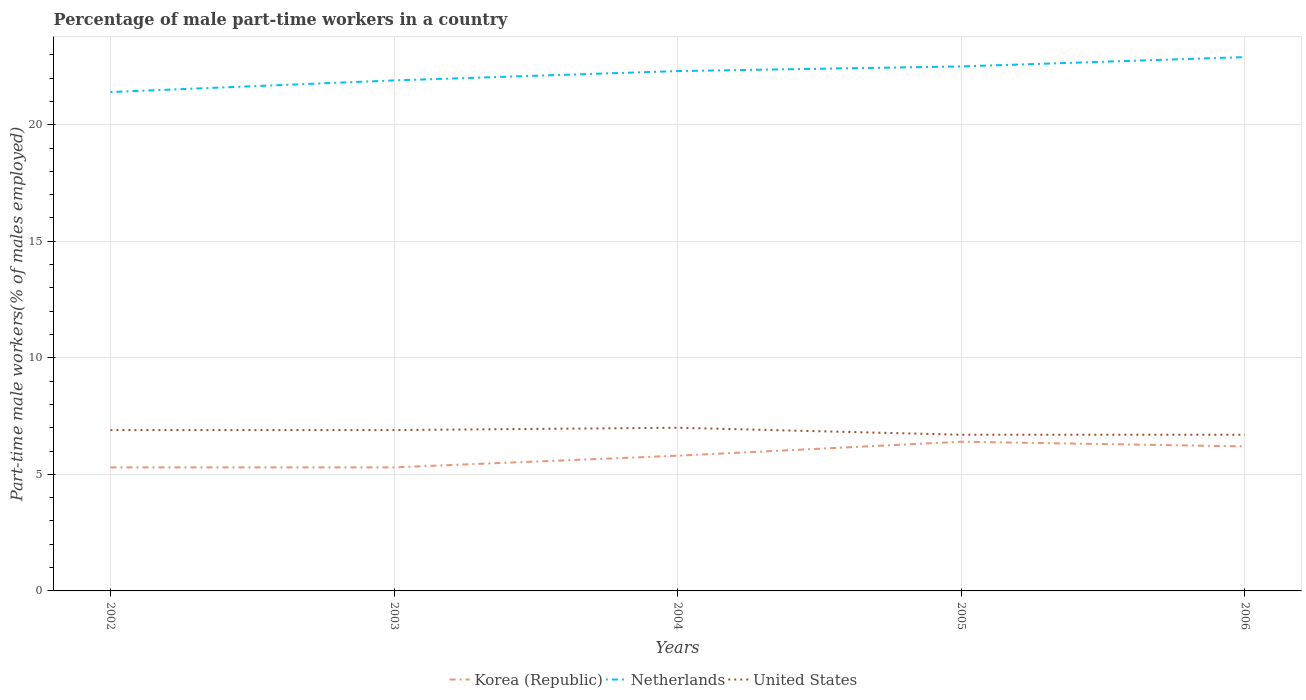How many different coloured lines are there?
Give a very brief answer. 3. Is the number of lines equal to the number of legend labels?
Your answer should be very brief. Yes. Across all years, what is the maximum percentage of male part-time workers in Netherlands?
Your response must be concise. 21.4. What is the total percentage of male part-time workers in United States in the graph?
Make the answer very short. 0. What is the difference between the highest and the second highest percentage of male part-time workers in Korea (Republic)?
Provide a short and direct response. 1.1. What is the difference between the highest and the lowest percentage of male part-time workers in Korea (Republic)?
Your answer should be compact. 3. How many lines are there?
Offer a very short reply. 3. Are the values on the major ticks of Y-axis written in scientific E-notation?
Provide a short and direct response. No. How are the legend labels stacked?
Provide a short and direct response. Horizontal. What is the title of the graph?
Your response must be concise. Percentage of male part-time workers in a country. What is the label or title of the X-axis?
Your answer should be compact. Years. What is the label or title of the Y-axis?
Give a very brief answer. Part-time male workers(% of males employed). What is the Part-time male workers(% of males employed) of Korea (Republic) in 2002?
Your response must be concise. 5.3. What is the Part-time male workers(% of males employed) in Netherlands in 2002?
Keep it short and to the point. 21.4. What is the Part-time male workers(% of males employed) of United States in 2002?
Your response must be concise. 6.9. What is the Part-time male workers(% of males employed) of Korea (Republic) in 2003?
Your response must be concise. 5.3. What is the Part-time male workers(% of males employed) in Netherlands in 2003?
Ensure brevity in your answer.  21.9. What is the Part-time male workers(% of males employed) of United States in 2003?
Provide a short and direct response. 6.9. What is the Part-time male workers(% of males employed) of Korea (Republic) in 2004?
Offer a terse response. 5.8. What is the Part-time male workers(% of males employed) of Netherlands in 2004?
Give a very brief answer. 22.3. What is the Part-time male workers(% of males employed) in United States in 2004?
Provide a succinct answer. 7. What is the Part-time male workers(% of males employed) in Korea (Republic) in 2005?
Make the answer very short. 6.4. What is the Part-time male workers(% of males employed) in United States in 2005?
Provide a short and direct response. 6.7. What is the Part-time male workers(% of males employed) in Korea (Republic) in 2006?
Provide a succinct answer. 6.2. What is the Part-time male workers(% of males employed) in Netherlands in 2006?
Offer a very short reply. 22.9. What is the Part-time male workers(% of males employed) of United States in 2006?
Offer a terse response. 6.7. Across all years, what is the maximum Part-time male workers(% of males employed) in Korea (Republic)?
Give a very brief answer. 6.4. Across all years, what is the maximum Part-time male workers(% of males employed) of Netherlands?
Provide a succinct answer. 22.9. Across all years, what is the maximum Part-time male workers(% of males employed) of United States?
Ensure brevity in your answer.  7. Across all years, what is the minimum Part-time male workers(% of males employed) in Korea (Republic)?
Keep it short and to the point. 5.3. Across all years, what is the minimum Part-time male workers(% of males employed) of Netherlands?
Your answer should be compact. 21.4. Across all years, what is the minimum Part-time male workers(% of males employed) in United States?
Ensure brevity in your answer.  6.7. What is the total Part-time male workers(% of males employed) of Netherlands in the graph?
Offer a terse response. 111. What is the total Part-time male workers(% of males employed) in United States in the graph?
Provide a short and direct response. 34.2. What is the difference between the Part-time male workers(% of males employed) of Korea (Republic) in 2002 and that in 2003?
Your answer should be very brief. 0. What is the difference between the Part-time male workers(% of males employed) of United States in 2002 and that in 2003?
Your answer should be very brief. 0. What is the difference between the Part-time male workers(% of males employed) of Netherlands in 2002 and that in 2004?
Keep it short and to the point. -0.9. What is the difference between the Part-time male workers(% of males employed) in United States in 2002 and that in 2004?
Provide a succinct answer. -0.1. What is the difference between the Part-time male workers(% of males employed) in Korea (Republic) in 2002 and that in 2005?
Your answer should be compact. -1.1. What is the difference between the Part-time male workers(% of males employed) of Netherlands in 2002 and that in 2005?
Provide a succinct answer. -1.1. What is the difference between the Part-time male workers(% of males employed) in Netherlands in 2002 and that in 2006?
Offer a terse response. -1.5. What is the difference between the Part-time male workers(% of males employed) in United States in 2002 and that in 2006?
Provide a succinct answer. 0.2. What is the difference between the Part-time male workers(% of males employed) in Korea (Republic) in 2003 and that in 2004?
Keep it short and to the point. -0.5. What is the difference between the Part-time male workers(% of males employed) of Korea (Republic) in 2003 and that in 2005?
Provide a succinct answer. -1.1. What is the difference between the Part-time male workers(% of males employed) of Netherlands in 2003 and that in 2006?
Ensure brevity in your answer.  -1. What is the difference between the Part-time male workers(% of males employed) in United States in 2003 and that in 2006?
Your answer should be very brief. 0.2. What is the difference between the Part-time male workers(% of males employed) in Korea (Republic) in 2004 and that in 2006?
Your answer should be very brief. -0.4. What is the difference between the Part-time male workers(% of males employed) of United States in 2004 and that in 2006?
Offer a very short reply. 0.3. What is the difference between the Part-time male workers(% of males employed) of Korea (Republic) in 2005 and that in 2006?
Your answer should be very brief. 0.2. What is the difference between the Part-time male workers(% of males employed) in Netherlands in 2005 and that in 2006?
Keep it short and to the point. -0.4. What is the difference between the Part-time male workers(% of males employed) in United States in 2005 and that in 2006?
Keep it short and to the point. 0. What is the difference between the Part-time male workers(% of males employed) in Korea (Republic) in 2002 and the Part-time male workers(% of males employed) in Netherlands in 2003?
Make the answer very short. -16.6. What is the difference between the Part-time male workers(% of males employed) of Korea (Republic) in 2002 and the Part-time male workers(% of males employed) of United States in 2003?
Your response must be concise. -1.6. What is the difference between the Part-time male workers(% of males employed) in Korea (Republic) in 2002 and the Part-time male workers(% of males employed) in United States in 2004?
Give a very brief answer. -1.7. What is the difference between the Part-time male workers(% of males employed) of Korea (Republic) in 2002 and the Part-time male workers(% of males employed) of Netherlands in 2005?
Keep it short and to the point. -17.2. What is the difference between the Part-time male workers(% of males employed) in Korea (Republic) in 2002 and the Part-time male workers(% of males employed) in Netherlands in 2006?
Your answer should be very brief. -17.6. What is the difference between the Part-time male workers(% of males employed) in Korea (Republic) in 2002 and the Part-time male workers(% of males employed) in United States in 2006?
Offer a terse response. -1.4. What is the difference between the Part-time male workers(% of males employed) in Korea (Republic) in 2003 and the Part-time male workers(% of males employed) in Netherlands in 2004?
Ensure brevity in your answer.  -17. What is the difference between the Part-time male workers(% of males employed) of Korea (Republic) in 2003 and the Part-time male workers(% of males employed) of Netherlands in 2005?
Provide a succinct answer. -17.2. What is the difference between the Part-time male workers(% of males employed) of Korea (Republic) in 2003 and the Part-time male workers(% of males employed) of Netherlands in 2006?
Your answer should be compact. -17.6. What is the difference between the Part-time male workers(% of males employed) of Korea (Republic) in 2003 and the Part-time male workers(% of males employed) of United States in 2006?
Provide a succinct answer. -1.4. What is the difference between the Part-time male workers(% of males employed) in Korea (Republic) in 2004 and the Part-time male workers(% of males employed) in Netherlands in 2005?
Keep it short and to the point. -16.7. What is the difference between the Part-time male workers(% of males employed) of Korea (Republic) in 2004 and the Part-time male workers(% of males employed) of United States in 2005?
Keep it short and to the point. -0.9. What is the difference between the Part-time male workers(% of males employed) of Netherlands in 2004 and the Part-time male workers(% of males employed) of United States in 2005?
Provide a succinct answer. 15.6. What is the difference between the Part-time male workers(% of males employed) of Korea (Republic) in 2004 and the Part-time male workers(% of males employed) of Netherlands in 2006?
Provide a short and direct response. -17.1. What is the difference between the Part-time male workers(% of males employed) of Korea (Republic) in 2004 and the Part-time male workers(% of males employed) of United States in 2006?
Offer a terse response. -0.9. What is the difference between the Part-time male workers(% of males employed) in Korea (Republic) in 2005 and the Part-time male workers(% of males employed) in Netherlands in 2006?
Provide a succinct answer. -16.5. What is the difference between the Part-time male workers(% of males employed) of Netherlands in 2005 and the Part-time male workers(% of males employed) of United States in 2006?
Your answer should be compact. 15.8. What is the average Part-time male workers(% of males employed) of Korea (Republic) per year?
Make the answer very short. 5.8. What is the average Part-time male workers(% of males employed) of United States per year?
Ensure brevity in your answer.  6.84. In the year 2002, what is the difference between the Part-time male workers(% of males employed) in Korea (Republic) and Part-time male workers(% of males employed) in Netherlands?
Give a very brief answer. -16.1. In the year 2002, what is the difference between the Part-time male workers(% of males employed) in Korea (Republic) and Part-time male workers(% of males employed) in United States?
Offer a very short reply. -1.6. In the year 2002, what is the difference between the Part-time male workers(% of males employed) of Netherlands and Part-time male workers(% of males employed) of United States?
Offer a very short reply. 14.5. In the year 2003, what is the difference between the Part-time male workers(% of males employed) in Korea (Republic) and Part-time male workers(% of males employed) in Netherlands?
Keep it short and to the point. -16.6. In the year 2003, what is the difference between the Part-time male workers(% of males employed) of Korea (Republic) and Part-time male workers(% of males employed) of United States?
Provide a succinct answer. -1.6. In the year 2003, what is the difference between the Part-time male workers(% of males employed) in Netherlands and Part-time male workers(% of males employed) in United States?
Your answer should be compact. 15. In the year 2004, what is the difference between the Part-time male workers(% of males employed) of Korea (Republic) and Part-time male workers(% of males employed) of Netherlands?
Your answer should be very brief. -16.5. In the year 2005, what is the difference between the Part-time male workers(% of males employed) of Korea (Republic) and Part-time male workers(% of males employed) of Netherlands?
Keep it short and to the point. -16.1. In the year 2006, what is the difference between the Part-time male workers(% of males employed) in Korea (Republic) and Part-time male workers(% of males employed) in Netherlands?
Your answer should be compact. -16.7. In the year 2006, what is the difference between the Part-time male workers(% of males employed) of Korea (Republic) and Part-time male workers(% of males employed) of United States?
Make the answer very short. -0.5. In the year 2006, what is the difference between the Part-time male workers(% of males employed) in Netherlands and Part-time male workers(% of males employed) in United States?
Give a very brief answer. 16.2. What is the ratio of the Part-time male workers(% of males employed) of Korea (Republic) in 2002 to that in 2003?
Provide a short and direct response. 1. What is the ratio of the Part-time male workers(% of males employed) of Netherlands in 2002 to that in 2003?
Your answer should be compact. 0.98. What is the ratio of the Part-time male workers(% of males employed) of United States in 2002 to that in 2003?
Provide a succinct answer. 1. What is the ratio of the Part-time male workers(% of males employed) in Korea (Republic) in 2002 to that in 2004?
Provide a short and direct response. 0.91. What is the ratio of the Part-time male workers(% of males employed) in Netherlands in 2002 to that in 2004?
Provide a short and direct response. 0.96. What is the ratio of the Part-time male workers(% of males employed) in United States in 2002 to that in 2004?
Provide a succinct answer. 0.99. What is the ratio of the Part-time male workers(% of males employed) in Korea (Republic) in 2002 to that in 2005?
Your answer should be very brief. 0.83. What is the ratio of the Part-time male workers(% of males employed) of Netherlands in 2002 to that in 2005?
Your answer should be compact. 0.95. What is the ratio of the Part-time male workers(% of males employed) of United States in 2002 to that in 2005?
Provide a short and direct response. 1.03. What is the ratio of the Part-time male workers(% of males employed) in Korea (Republic) in 2002 to that in 2006?
Give a very brief answer. 0.85. What is the ratio of the Part-time male workers(% of males employed) of Netherlands in 2002 to that in 2006?
Your answer should be very brief. 0.93. What is the ratio of the Part-time male workers(% of males employed) in United States in 2002 to that in 2006?
Ensure brevity in your answer.  1.03. What is the ratio of the Part-time male workers(% of males employed) in Korea (Republic) in 2003 to that in 2004?
Your answer should be compact. 0.91. What is the ratio of the Part-time male workers(% of males employed) in Netherlands in 2003 to that in 2004?
Provide a succinct answer. 0.98. What is the ratio of the Part-time male workers(% of males employed) in United States in 2003 to that in 2004?
Your answer should be compact. 0.99. What is the ratio of the Part-time male workers(% of males employed) of Korea (Republic) in 2003 to that in 2005?
Your answer should be very brief. 0.83. What is the ratio of the Part-time male workers(% of males employed) of Netherlands in 2003 to that in 2005?
Give a very brief answer. 0.97. What is the ratio of the Part-time male workers(% of males employed) in United States in 2003 to that in 2005?
Give a very brief answer. 1.03. What is the ratio of the Part-time male workers(% of males employed) in Korea (Republic) in 2003 to that in 2006?
Ensure brevity in your answer.  0.85. What is the ratio of the Part-time male workers(% of males employed) of Netherlands in 2003 to that in 2006?
Offer a terse response. 0.96. What is the ratio of the Part-time male workers(% of males employed) in United States in 2003 to that in 2006?
Make the answer very short. 1.03. What is the ratio of the Part-time male workers(% of males employed) of Korea (Republic) in 2004 to that in 2005?
Your response must be concise. 0.91. What is the ratio of the Part-time male workers(% of males employed) in United States in 2004 to that in 2005?
Your response must be concise. 1.04. What is the ratio of the Part-time male workers(% of males employed) in Korea (Republic) in 2004 to that in 2006?
Offer a terse response. 0.94. What is the ratio of the Part-time male workers(% of males employed) in Netherlands in 2004 to that in 2006?
Keep it short and to the point. 0.97. What is the ratio of the Part-time male workers(% of males employed) in United States in 2004 to that in 2006?
Provide a short and direct response. 1.04. What is the ratio of the Part-time male workers(% of males employed) in Korea (Republic) in 2005 to that in 2006?
Ensure brevity in your answer.  1.03. What is the ratio of the Part-time male workers(% of males employed) in Netherlands in 2005 to that in 2006?
Provide a short and direct response. 0.98. What is the ratio of the Part-time male workers(% of males employed) of United States in 2005 to that in 2006?
Make the answer very short. 1. What is the difference between the highest and the second highest Part-time male workers(% of males employed) in Korea (Republic)?
Provide a short and direct response. 0.2. What is the difference between the highest and the second highest Part-time male workers(% of males employed) in Netherlands?
Make the answer very short. 0.4. What is the difference between the highest and the lowest Part-time male workers(% of males employed) of Korea (Republic)?
Provide a succinct answer. 1.1. 